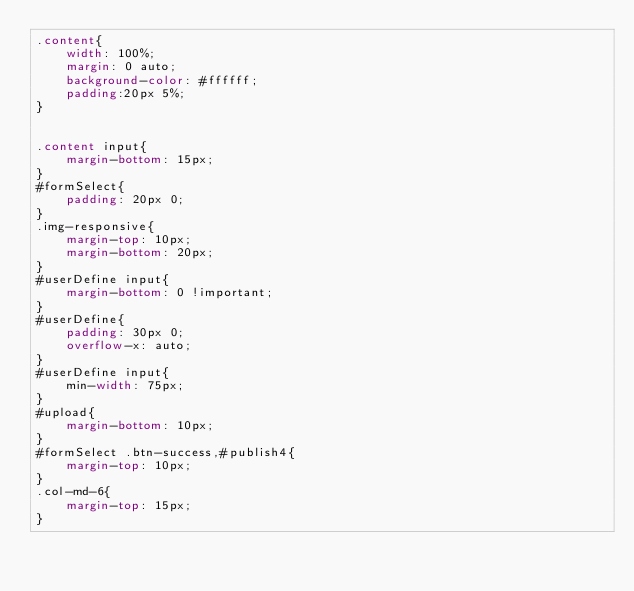Convert code to text. <code><loc_0><loc_0><loc_500><loc_500><_CSS_>.content{
    width: 100%;
    margin: 0 auto;
    background-color: #ffffff;
    padding:20px 5%;
}


.content input{
    margin-bottom: 15px;
}
#formSelect{
    padding: 20px 0;
}
.img-responsive{
    margin-top: 10px;
    margin-bottom: 20px;
}
#userDefine input{
    margin-bottom: 0 !important;
}
#userDefine{
    padding: 30px 0;
    overflow-x: auto;
}
#userDefine input{
    min-width: 75px;
}
#upload{
    margin-bottom: 10px;
}
#formSelect .btn-success,#publish4{
    margin-top: 10px;
}
.col-md-6{
    margin-top: 15px;
}

</code> 